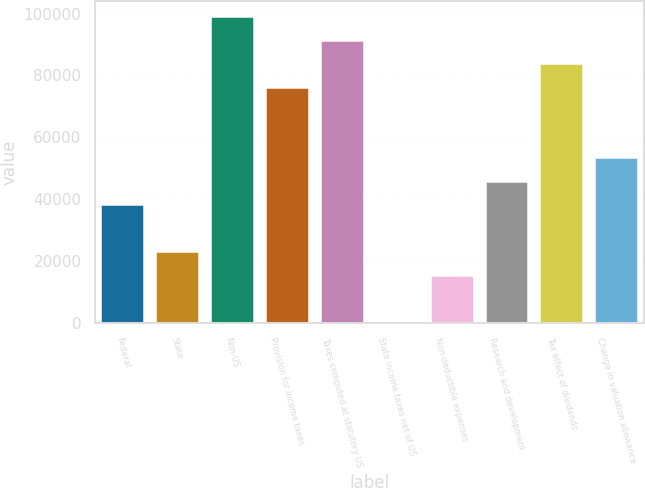<chart> <loc_0><loc_0><loc_500><loc_500><bar_chart><fcel>Federal<fcel>State<fcel>Non-US<fcel>Provision for income taxes<fcel>Taxes computed at statutory US<fcel>State income taxes net of US<fcel>Non-deductible expenses<fcel>Research and development<fcel>Tax effect of dividends<fcel>Change in valuation allowance<nl><fcel>38362.5<fcel>23155.9<fcel>99188.9<fcel>76379<fcel>91585.6<fcel>346<fcel>15552.6<fcel>45965.8<fcel>83982.3<fcel>53569.1<nl></chart> 